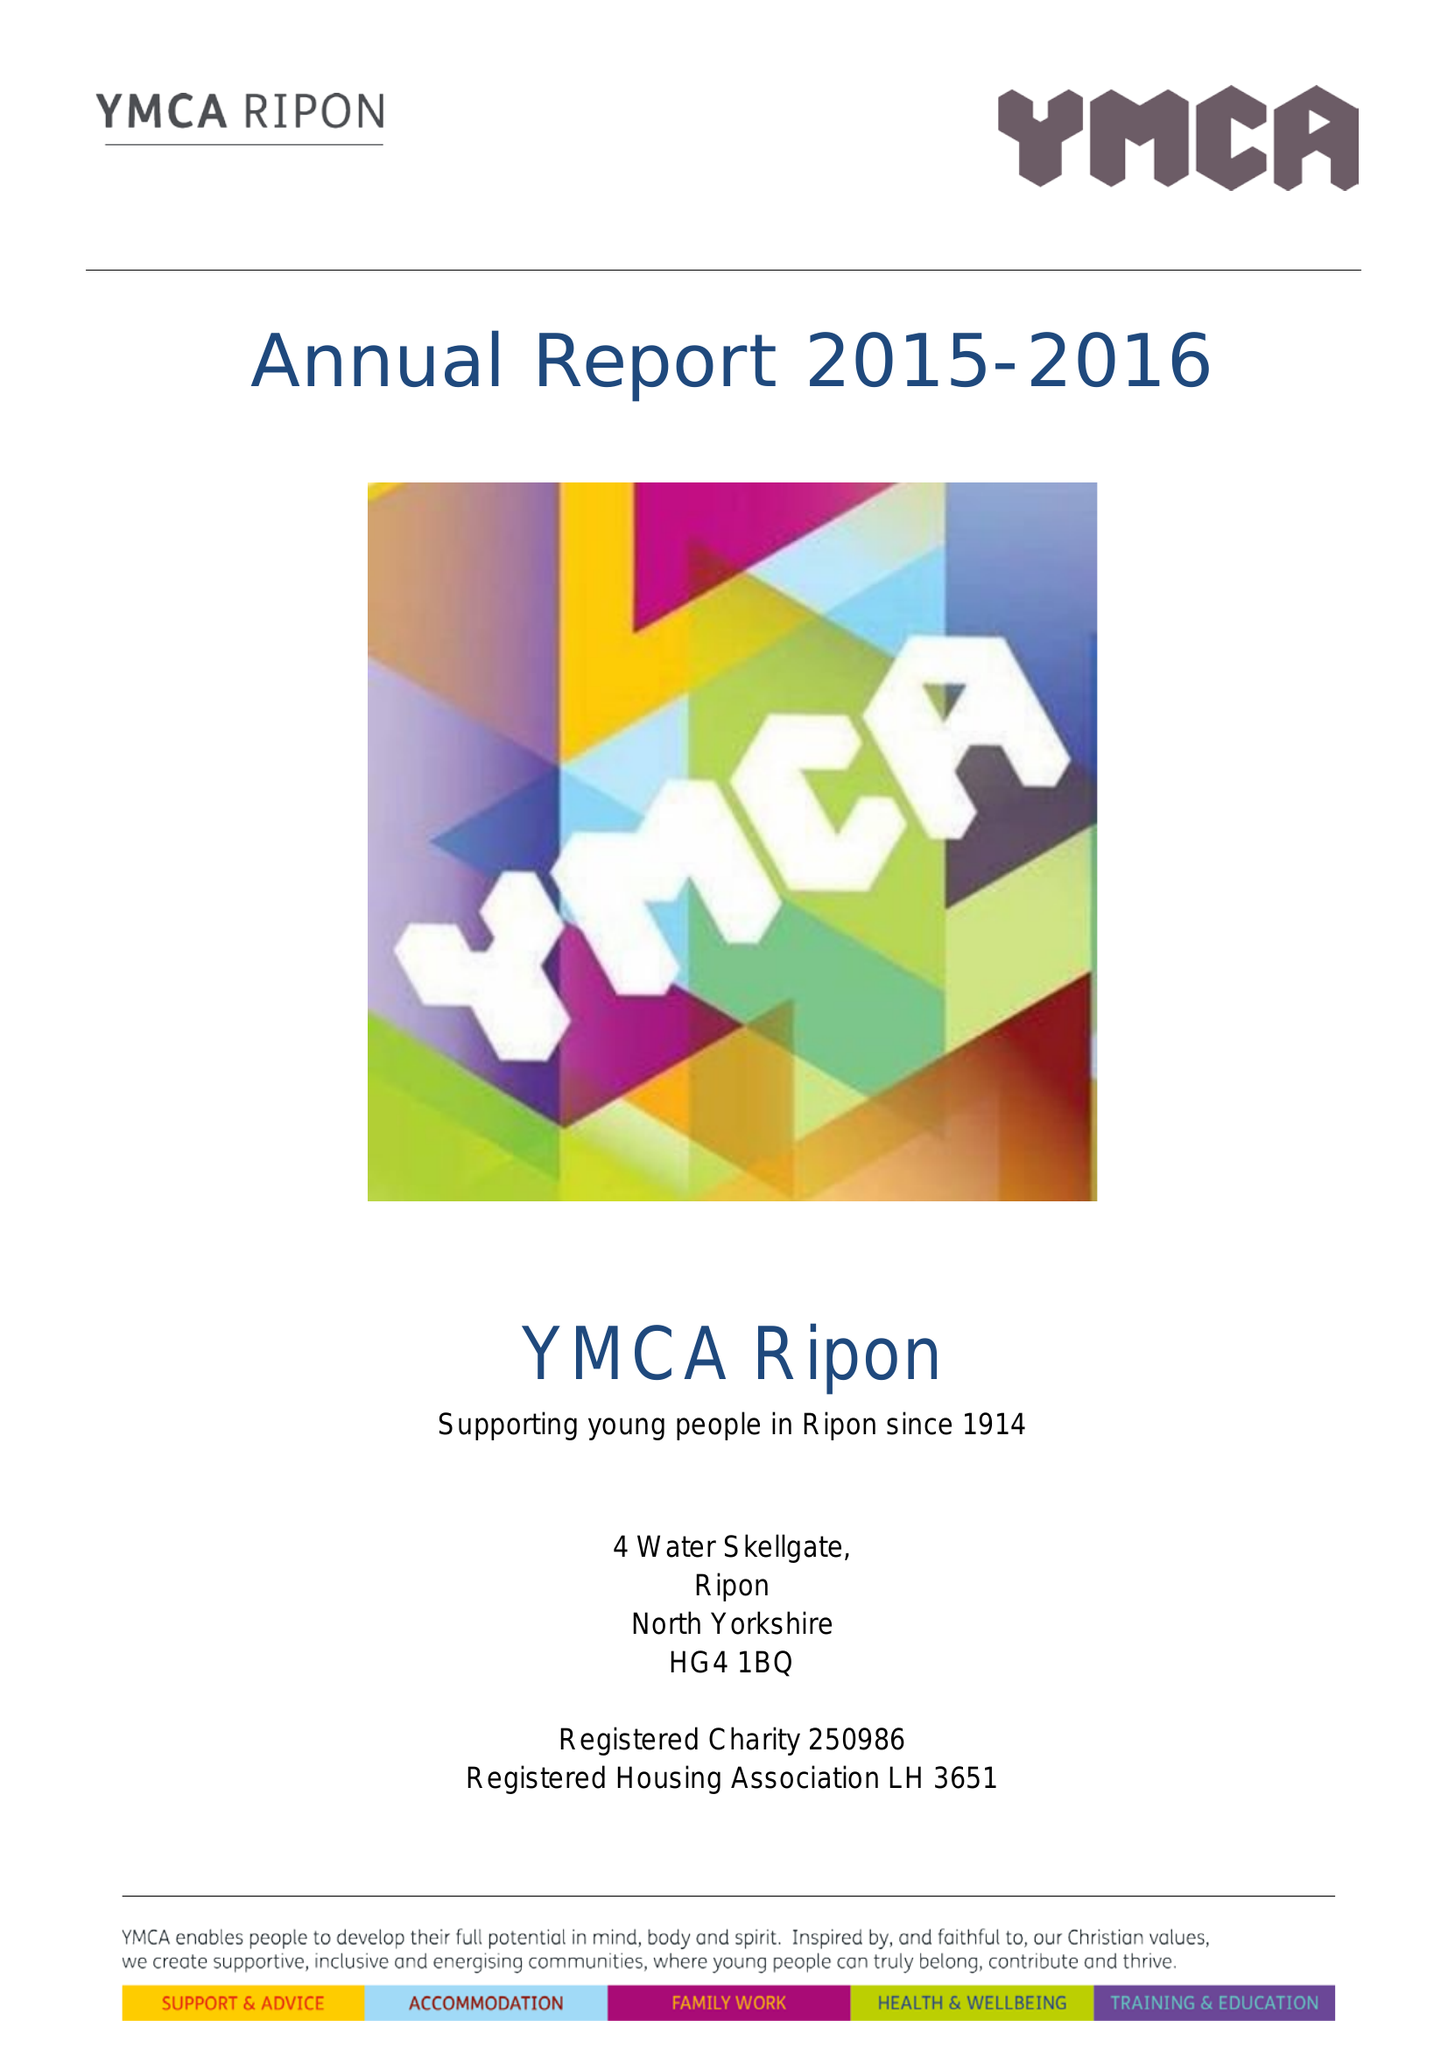What is the value for the charity_name?
Answer the question using a single word or phrase. Ripon Young Men's Christian Association 